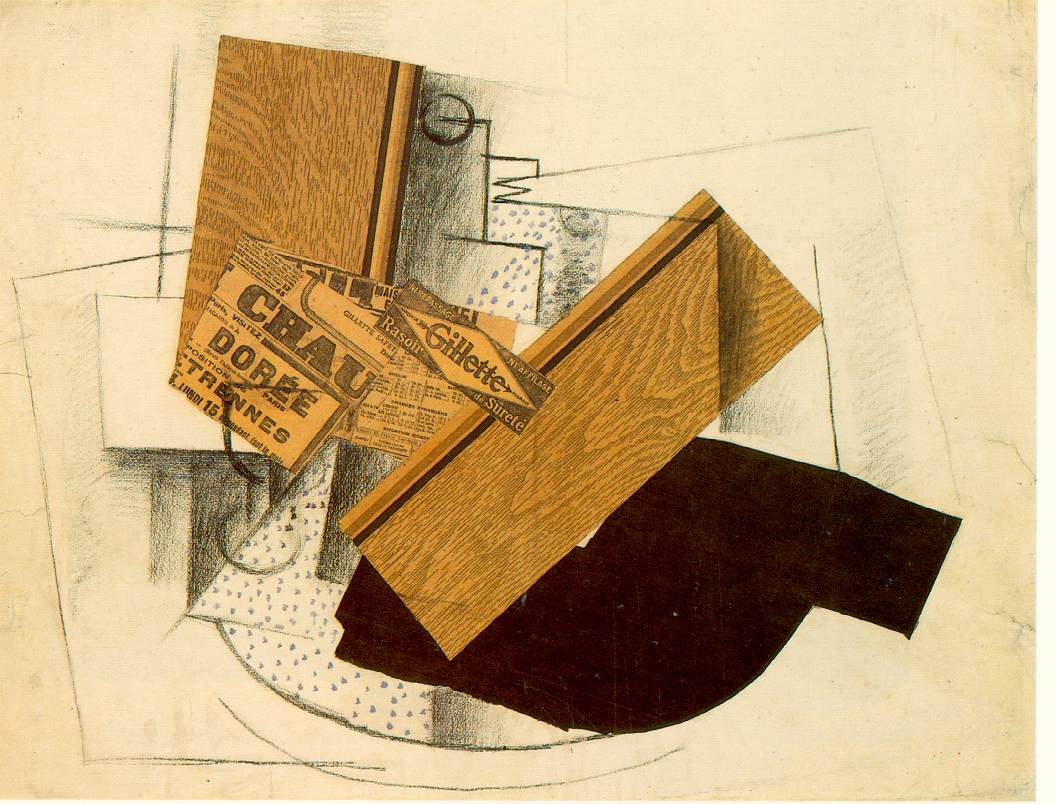How does the color palette employed in the artwork affect its mood and message? The color palette of this artwork, primarily consisting of earthy browns, stark blacks, and muted whites, contributes significantly to its overall mood and thematic expression. The subdued colors might suggest a somber or reflective mood, possibly highlighting the seriousness of the themes tackled by cubism, such as the complexity of modern life and the multifaceted nature of reality. Moreover, the contrast between the black shapes and the lighter background can emphasize the dramatic impact of new perspectives and ideologies breaking through traditional boundaries. What could the wooden texture symbolize in the context of the other elements? In the context of the other elements in the artwork, the wooden texture might symbolize the natural world or traditional materials, standing in stark contrast to the modern, manufactured appearance of the newspaper clipping. This juxtaposition could be highlighting the tension between the natural and the artificial, a common theme in art that reflects on how industrialization and modernization have altered human interaction with the natural environment. The texture adds a tactile quality that may invoke thoughts about the 'real' versus the 'constructed' in life and art. 